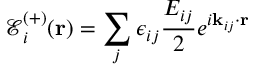<formula> <loc_0><loc_0><loc_500><loc_500>\mathcal { E } _ { i } ^ { ( + ) } ( r ) = \sum _ { j } \epsilon _ { i j } \frac { E _ { i j } } { 2 } e ^ { i k _ { i j } \cdot r }</formula> 